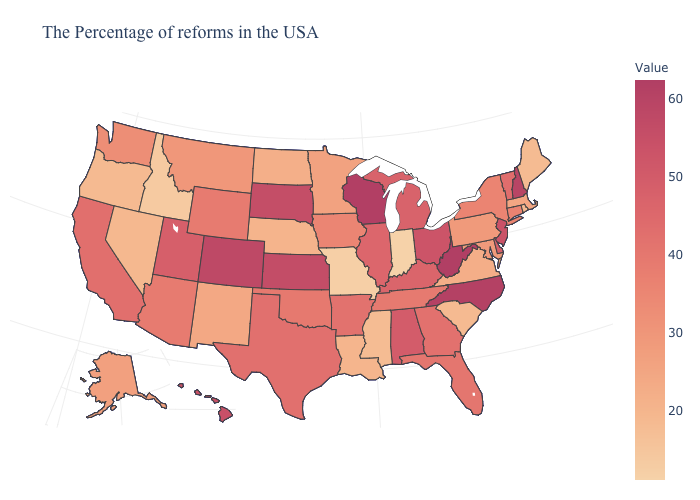Which states have the lowest value in the USA?
Write a very short answer. Indiana. Does Delaware have a lower value than Massachusetts?
Concise answer only. No. Does Arizona have a higher value than Kansas?
Write a very short answer. No. Among the states that border Nebraska , does Colorado have the highest value?
Give a very brief answer. Yes. Among the states that border Louisiana , does Arkansas have the lowest value?
Give a very brief answer. No. Among the states that border New Hampshire , which have the lowest value?
Quick response, please. Maine. 